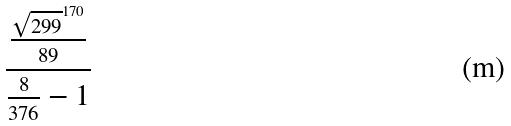Convert formula to latex. <formula><loc_0><loc_0><loc_500><loc_500>\frac { \frac { \sqrt { 2 9 9 } ^ { 1 7 0 } } { 8 9 } } { \frac { 8 } { 3 7 6 } - 1 }</formula> 